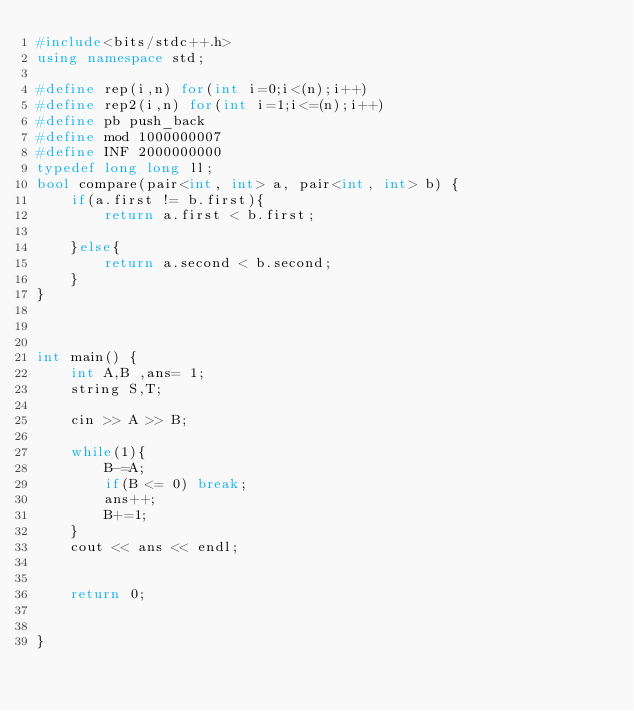Convert code to text. <code><loc_0><loc_0><loc_500><loc_500><_C++_>#include<bits/stdc++.h>
using namespace std;

#define rep(i,n) for(int i=0;i<(n);i++)
#define rep2(i,n) for(int i=1;i<=(n);i++)
#define pb push_back
#define mod 1000000007
#define INF 2000000000
typedef long long ll;
bool compare(pair<int, int> a, pair<int, int> b) {
    if(a.first != b.first){
        return a.first < b.first;
        
    }else{
        return a.second < b.second;
    }
}



int main() {
    int A,B ,ans= 1;
    string S,T;

    cin >> A >> B;

    while(1){
        B-=A;
        if(B <= 0) break;
        ans++;
        B+=1;
    }
    cout << ans << endl;
    
    
    return 0;
    

}</code> 